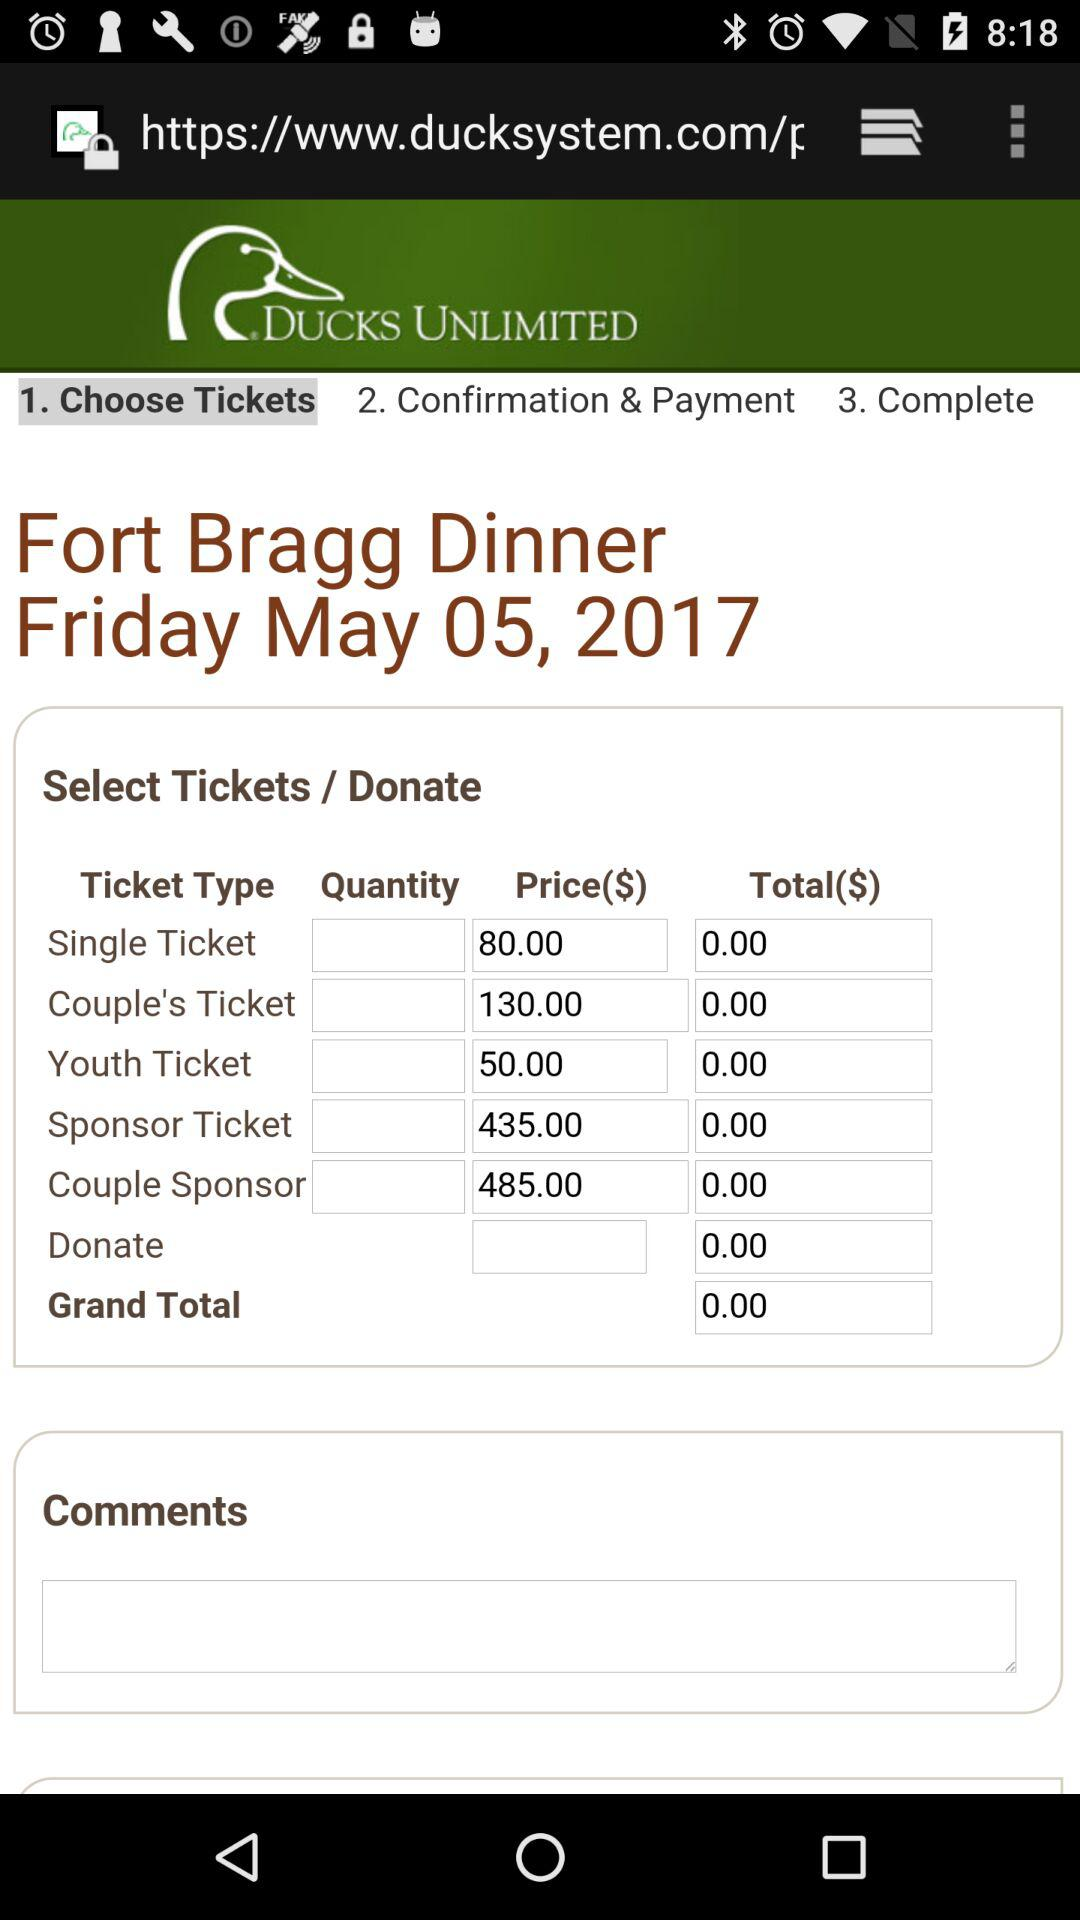What is the date? The date is Friday, May 5, 2017. 